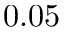Convert formula to latex. <formula><loc_0><loc_0><loc_500><loc_500>0 . 0 5</formula> 